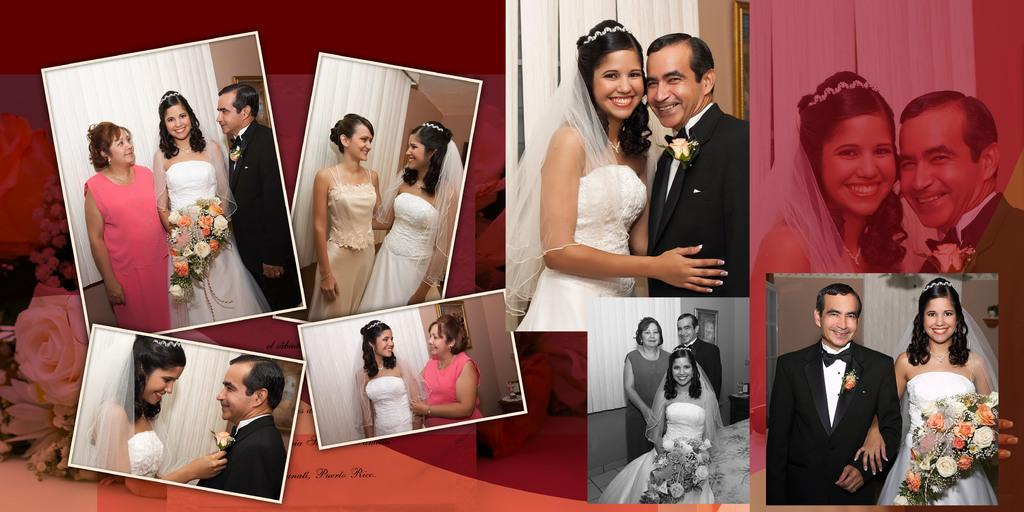What type of event might the pictures in the image be related to? The pictures of a bride and bridegroom in the image suggest a wedding or marriage-related event. Can you describe the people in the image? There are people in the image, but their specific appearance or actions are not mentioned in the provided facts. What type of window treatment is visible in the image? There are blinds in the image. What might the flower bouquet be used for in the context of the image? The flower bouquet in the image might be used as a decorative element or as part of a wedding ceremony. What can be read or deciphered from the text in the image? The provided facts do not specify the content of the text visible in the image. What scientific discovery is being celebrated in the image? There is no mention of a scientific discovery in the image or the provided facts. What type of reward is being given to the bride and bridegroom in the image? There is no mention of a reward being given to the bride and bridegroom in the image or the provided facts. 